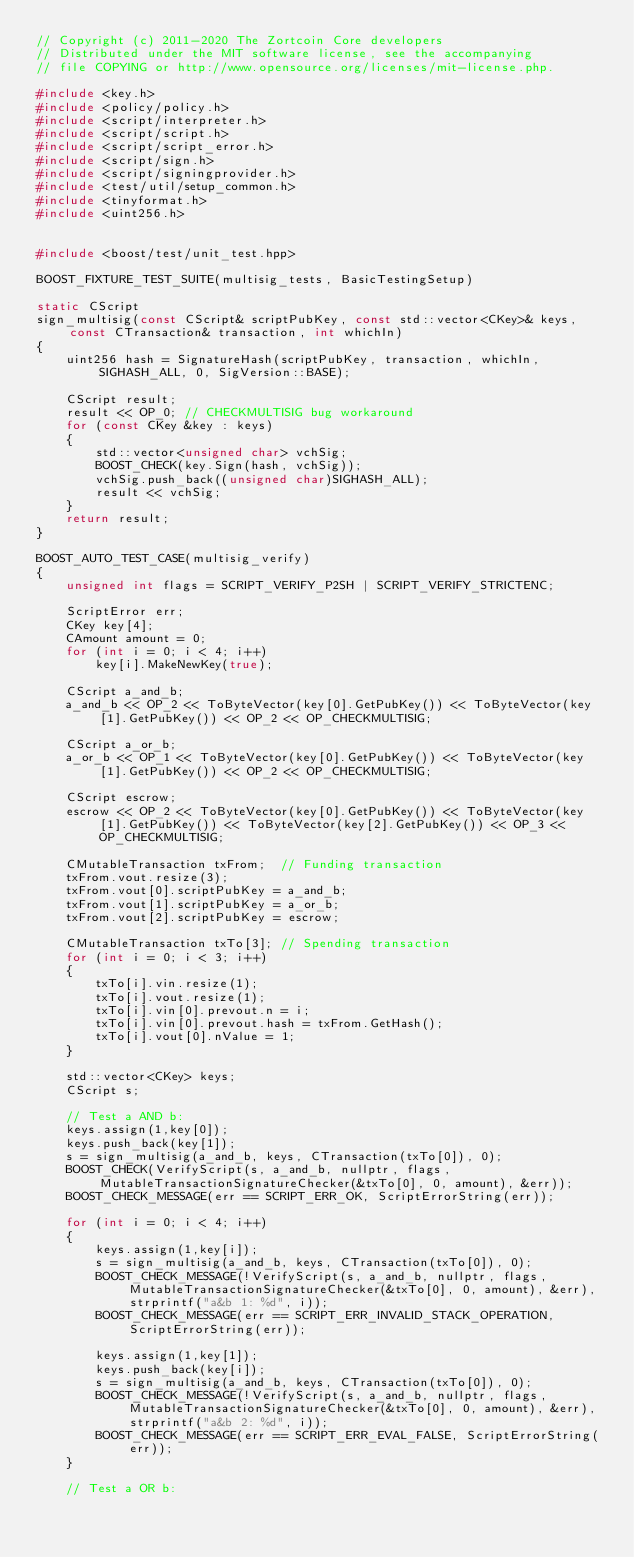Convert code to text. <code><loc_0><loc_0><loc_500><loc_500><_C++_>// Copyright (c) 2011-2020 The Zortcoin Core developers
// Distributed under the MIT software license, see the accompanying
// file COPYING or http://www.opensource.org/licenses/mit-license.php.

#include <key.h>
#include <policy/policy.h>
#include <script/interpreter.h>
#include <script/script.h>
#include <script/script_error.h>
#include <script/sign.h>
#include <script/signingprovider.h>
#include <test/util/setup_common.h>
#include <tinyformat.h>
#include <uint256.h>


#include <boost/test/unit_test.hpp>

BOOST_FIXTURE_TEST_SUITE(multisig_tests, BasicTestingSetup)

static CScript
sign_multisig(const CScript& scriptPubKey, const std::vector<CKey>& keys, const CTransaction& transaction, int whichIn)
{
    uint256 hash = SignatureHash(scriptPubKey, transaction, whichIn, SIGHASH_ALL, 0, SigVersion::BASE);

    CScript result;
    result << OP_0; // CHECKMULTISIG bug workaround
    for (const CKey &key : keys)
    {
        std::vector<unsigned char> vchSig;
        BOOST_CHECK(key.Sign(hash, vchSig));
        vchSig.push_back((unsigned char)SIGHASH_ALL);
        result << vchSig;
    }
    return result;
}

BOOST_AUTO_TEST_CASE(multisig_verify)
{
    unsigned int flags = SCRIPT_VERIFY_P2SH | SCRIPT_VERIFY_STRICTENC;

    ScriptError err;
    CKey key[4];
    CAmount amount = 0;
    for (int i = 0; i < 4; i++)
        key[i].MakeNewKey(true);

    CScript a_and_b;
    a_and_b << OP_2 << ToByteVector(key[0].GetPubKey()) << ToByteVector(key[1].GetPubKey()) << OP_2 << OP_CHECKMULTISIG;

    CScript a_or_b;
    a_or_b << OP_1 << ToByteVector(key[0].GetPubKey()) << ToByteVector(key[1].GetPubKey()) << OP_2 << OP_CHECKMULTISIG;

    CScript escrow;
    escrow << OP_2 << ToByteVector(key[0].GetPubKey()) << ToByteVector(key[1].GetPubKey()) << ToByteVector(key[2].GetPubKey()) << OP_3 << OP_CHECKMULTISIG;

    CMutableTransaction txFrom;  // Funding transaction
    txFrom.vout.resize(3);
    txFrom.vout[0].scriptPubKey = a_and_b;
    txFrom.vout[1].scriptPubKey = a_or_b;
    txFrom.vout[2].scriptPubKey = escrow;

    CMutableTransaction txTo[3]; // Spending transaction
    for (int i = 0; i < 3; i++)
    {
        txTo[i].vin.resize(1);
        txTo[i].vout.resize(1);
        txTo[i].vin[0].prevout.n = i;
        txTo[i].vin[0].prevout.hash = txFrom.GetHash();
        txTo[i].vout[0].nValue = 1;
    }

    std::vector<CKey> keys;
    CScript s;

    // Test a AND b:
    keys.assign(1,key[0]);
    keys.push_back(key[1]);
    s = sign_multisig(a_and_b, keys, CTransaction(txTo[0]), 0);
    BOOST_CHECK(VerifyScript(s, a_and_b, nullptr, flags, MutableTransactionSignatureChecker(&txTo[0], 0, amount), &err));
    BOOST_CHECK_MESSAGE(err == SCRIPT_ERR_OK, ScriptErrorString(err));

    for (int i = 0; i < 4; i++)
    {
        keys.assign(1,key[i]);
        s = sign_multisig(a_and_b, keys, CTransaction(txTo[0]), 0);
        BOOST_CHECK_MESSAGE(!VerifyScript(s, a_and_b, nullptr, flags, MutableTransactionSignatureChecker(&txTo[0], 0, amount), &err), strprintf("a&b 1: %d", i));
        BOOST_CHECK_MESSAGE(err == SCRIPT_ERR_INVALID_STACK_OPERATION, ScriptErrorString(err));

        keys.assign(1,key[1]);
        keys.push_back(key[i]);
        s = sign_multisig(a_and_b, keys, CTransaction(txTo[0]), 0);
        BOOST_CHECK_MESSAGE(!VerifyScript(s, a_and_b, nullptr, flags, MutableTransactionSignatureChecker(&txTo[0], 0, amount), &err), strprintf("a&b 2: %d", i));
        BOOST_CHECK_MESSAGE(err == SCRIPT_ERR_EVAL_FALSE, ScriptErrorString(err));
    }

    // Test a OR b:</code> 